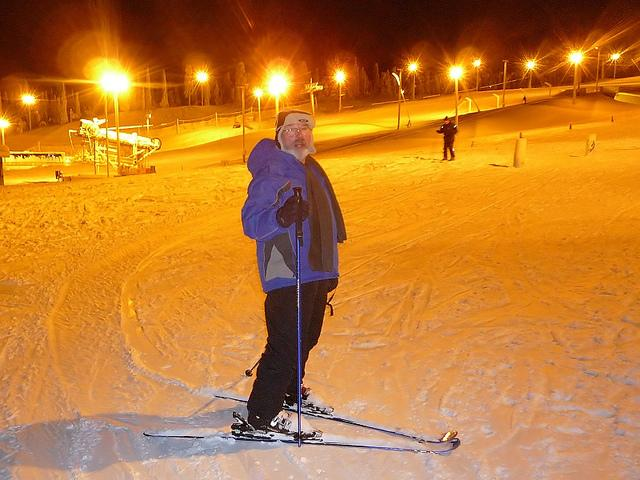Why is the man wearing a hat with earflaps? Please explain your reasoning. warmth. The man is cold in the snow. 